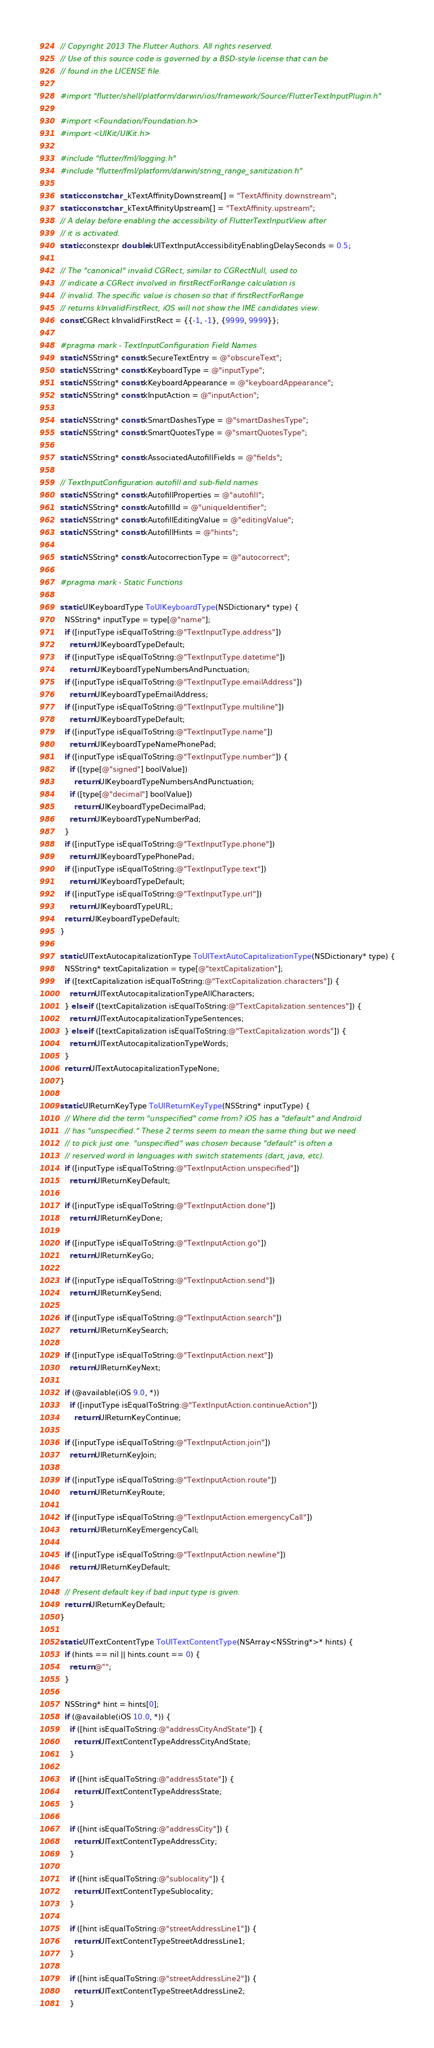Convert code to text. <code><loc_0><loc_0><loc_500><loc_500><_ObjectiveC_>// Copyright 2013 The Flutter Authors. All rights reserved.
// Use of this source code is governed by a BSD-style license that can be
// found in the LICENSE file.

#import "flutter/shell/platform/darwin/ios/framework/Source/FlutterTextInputPlugin.h"

#import <Foundation/Foundation.h>
#import <UIKit/UIKit.h>

#include "flutter/fml/logging.h"
#include "flutter/fml/platform/darwin/string_range_sanitization.h"

static const char _kTextAffinityDownstream[] = "TextAffinity.downstream";
static const char _kTextAffinityUpstream[] = "TextAffinity.upstream";
// A delay before enabling the accessibility of FlutterTextInputView after
// it is activated.
static constexpr double kUITextInputAccessibilityEnablingDelaySeconds = 0.5;

// The "canonical" invalid CGRect, similar to CGRectNull, used to
// indicate a CGRect involved in firstRectForRange calculation is
// invalid. The specific value is chosen so that if firstRectForRange
// returns kInvalidFirstRect, iOS will not show the IME candidates view.
const CGRect kInvalidFirstRect = {{-1, -1}, {9999, 9999}};

#pragma mark - TextInputConfiguration Field Names
static NSString* const kSecureTextEntry = @"obscureText";
static NSString* const kKeyboardType = @"inputType";
static NSString* const kKeyboardAppearance = @"keyboardAppearance";
static NSString* const kInputAction = @"inputAction";

static NSString* const kSmartDashesType = @"smartDashesType";
static NSString* const kSmartQuotesType = @"smartQuotesType";

static NSString* const kAssociatedAutofillFields = @"fields";

// TextInputConfiguration.autofill and sub-field names
static NSString* const kAutofillProperties = @"autofill";
static NSString* const kAutofillId = @"uniqueIdentifier";
static NSString* const kAutofillEditingValue = @"editingValue";
static NSString* const kAutofillHints = @"hints";

static NSString* const kAutocorrectionType = @"autocorrect";

#pragma mark - Static Functions

static UIKeyboardType ToUIKeyboardType(NSDictionary* type) {
  NSString* inputType = type[@"name"];
  if ([inputType isEqualToString:@"TextInputType.address"])
    return UIKeyboardTypeDefault;
  if ([inputType isEqualToString:@"TextInputType.datetime"])
    return UIKeyboardTypeNumbersAndPunctuation;
  if ([inputType isEqualToString:@"TextInputType.emailAddress"])
    return UIKeyboardTypeEmailAddress;
  if ([inputType isEqualToString:@"TextInputType.multiline"])
    return UIKeyboardTypeDefault;
  if ([inputType isEqualToString:@"TextInputType.name"])
    return UIKeyboardTypeNamePhonePad;
  if ([inputType isEqualToString:@"TextInputType.number"]) {
    if ([type[@"signed"] boolValue])
      return UIKeyboardTypeNumbersAndPunctuation;
    if ([type[@"decimal"] boolValue])
      return UIKeyboardTypeDecimalPad;
    return UIKeyboardTypeNumberPad;
  }
  if ([inputType isEqualToString:@"TextInputType.phone"])
    return UIKeyboardTypePhonePad;
  if ([inputType isEqualToString:@"TextInputType.text"])
    return UIKeyboardTypeDefault;
  if ([inputType isEqualToString:@"TextInputType.url"])
    return UIKeyboardTypeURL;
  return UIKeyboardTypeDefault;
}

static UITextAutocapitalizationType ToUITextAutoCapitalizationType(NSDictionary* type) {
  NSString* textCapitalization = type[@"textCapitalization"];
  if ([textCapitalization isEqualToString:@"TextCapitalization.characters"]) {
    return UITextAutocapitalizationTypeAllCharacters;
  } else if ([textCapitalization isEqualToString:@"TextCapitalization.sentences"]) {
    return UITextAutocapitalizationTypeSentences;
  } else if ([textCapitalization isEqualToString:@"TextCapitalization.words"]) {
    return UITextAutocapitalizationTypeWords;
  }
  return UITextAutocapitalizationTypeNone;
}

static UIReturnKeyType ToUIReturnKeyType(NSString* inputType) {
  // Where did the term "unspecified" come from? iOS has a "default" and Android
  // has "unspecified." These 2 terms seem to mean the same thing but we need
  // to pick just one. "unspecified" was chosen because "default" is often a
  // reserved word in languages with switch statements (dart, java, etc).
  if ([inputType isEqualToString:@"TextInputAction.unspecified"])
    return UIReturnKeyDefault;

  if ([inputType isEqualToString:@"TextInputAction.done"])
    return UIReturnKeyDone;

  if ([inputType isEqualToString:@"TextInputAction.go"])
    return UIReturnKeyGo;

  if ([inputType isEqualToString:@"TextInputAction.send"])
    return UIReturnKeySend;

  if ([inputType isEqualToString:@"TextInputAction.search"])
    return UIReturnKeySearch;

  if ([inputType isEqualToString:@"TextInputAction.next"])
    return UIReturnKeyNext;

  if (@available(iOS 9.0, *))
    if ([inputType isEqualToString:@"TextInputAction.continueAction"])
      return UIReturnKeyContinue;

  if ([inputType isEqualToString:@"TextInputAction.join"])
    return UIReturnKeyJoin;

  if ([inputType isEqualToString:@"TextInputAction.route"])
    return UIReturnKeyRoute;

  if ([inputType isEqualToString:@"TextInputAction.emergencyCall"])
    return UIReturnKeyEmergencyCall;

  if ([inputType isEqualToString:@"TextInputAction.newline"])
    return UIReturnKeyDefault;

  // Present default key if bad input type is given.
  return UIReturnKeyDefault;
}

static UITextContentType ToUITextContentType(NSArray<NSString*>* hints) {
  if (hints == nil || hints.count == 0) {
    return @"";
  }

  NSString* hint = hints[0];
  if (@available(iOS 10.0, *)) {
    if ([hint isEqualToString:@"addressCityAndState"]) {
      return UITextContentTypeAddressCityAndState;
    }

    if ([hint isEqualToString:@"addressState"]) {
      return UITextContentTypeAddressState;
    }

    if ([hint isEqualToString:@"addressCity"]) {
      return UITextContentTypeAddressCity;
    }

    if ([hint isEqualToString:@"sublocality"]) {
      return UITextContentTypeSublocality;
    }

    if ([hint isEqualToString:@"streetAddressLine1"]) {
      return UITextContentTypeStreetAddressLine1;
    }

    if ([hint isEqualToString:@"streetAddressLine2"]) {
      return UITextContentTypeStreetAddressLine2;
    }
</code> 